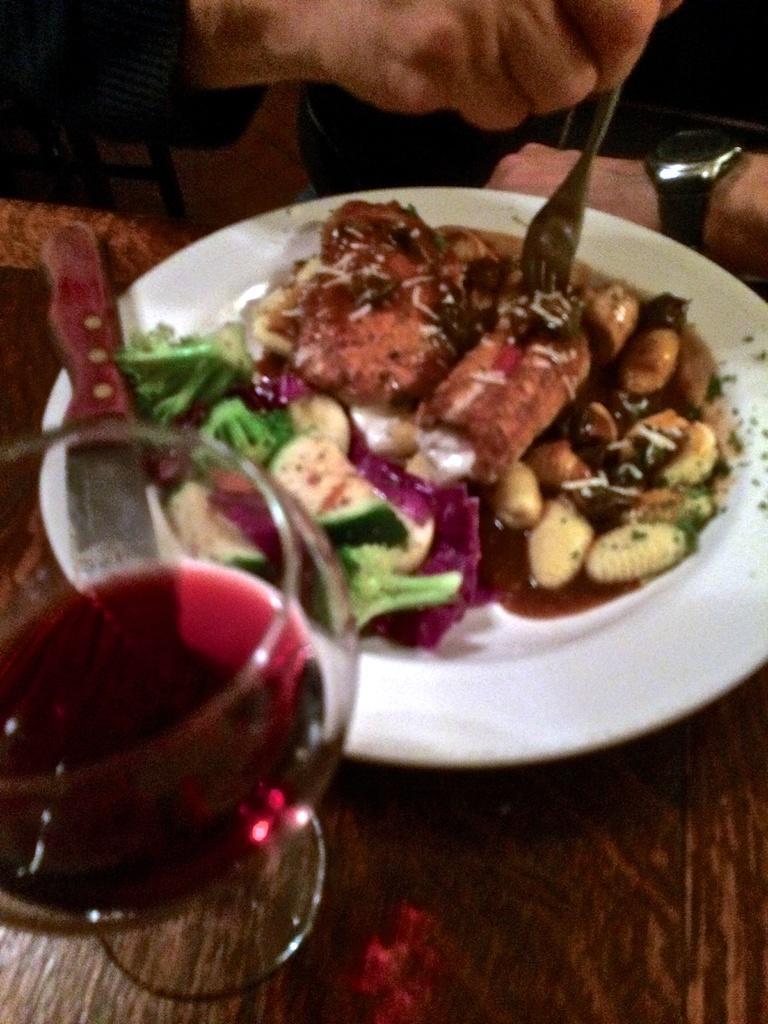In one or two sentences, can you explain what this image depicts? In this image we can a plate containing some food and a knife in it and a glass which are placed on the table. We can also see a person holding a fork. 